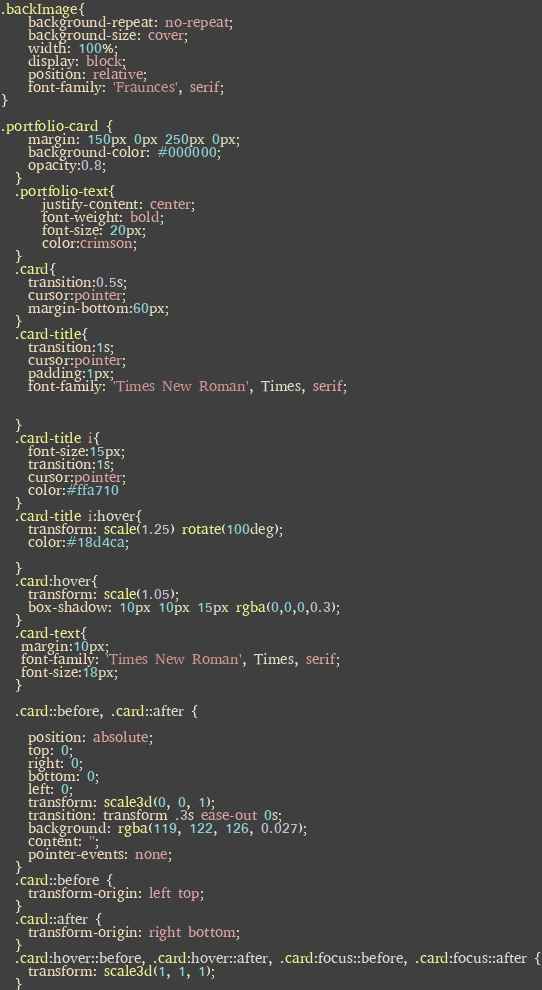Convert code to text. <code><loc_0><loc_0><loc_500><loc_500><_CSS_>.backImage{
    background-repeat: no-repeat;
    background-size: cover;
    width: 100%;
    display: block;
    position: relative;
    font-family: 'Fraunces', serif;
}

.portfolio-card {
    margin: 150px 0px 250px 0px;
    background-color: #000000;
    opacity:0.8; 
  }
  .portfolio-text{
      justify-content: center;
      font-weight: bold;
      font-size: 20px;
      color:crimson;
  }
  .card{
    transition:0.5s;
    cursor:pointer;
    margin-bottom:60px;
  }
  .card-title{  
    transition:1s;
    cursor:pointer;
    padding:1px;
    font-family: 'Times New Roman', Times, serif;
  
   
  }
  .card-title i{  
    font-size:15px;
    transition:1s;
    cursor:pointer;
    color:#ffa710
  }
  .card-title i:hover{
    transform: scale(1.25) rotate(100deg); 
    color:#18d4ca;
    
  }
  .card:hover{
    transform: scale(1.05);
    box-shadow: 10px 10px 15px rgba(0,0,0,0.3);
  }
  .card-text{
   margin:10px;
   font-family: 'Times New Roman', Times, serif;
   font-size:18px;
  }
  
  .card::before, .card::after {
   
    position: absolute;
    top: 0;
    right: 0;
    bottom: 0;
    left: 0;
    transform: scale3d(0, 0, 1);
    transition: transform .3s ease-out 0s;
    background: rgba(119, 122, 126, 0.027);
    content: '';
    pointer-events: none;
  }
  .card::before {
    transform-origin: left top;
  }
  .card::after {
    transform-origin: right bottom;
  }
  .card:hover::before, .card:hover::after, .card:focus::before, .card:focus::after {
    transform: scale3d(1, 1, 1);
  }</code> 